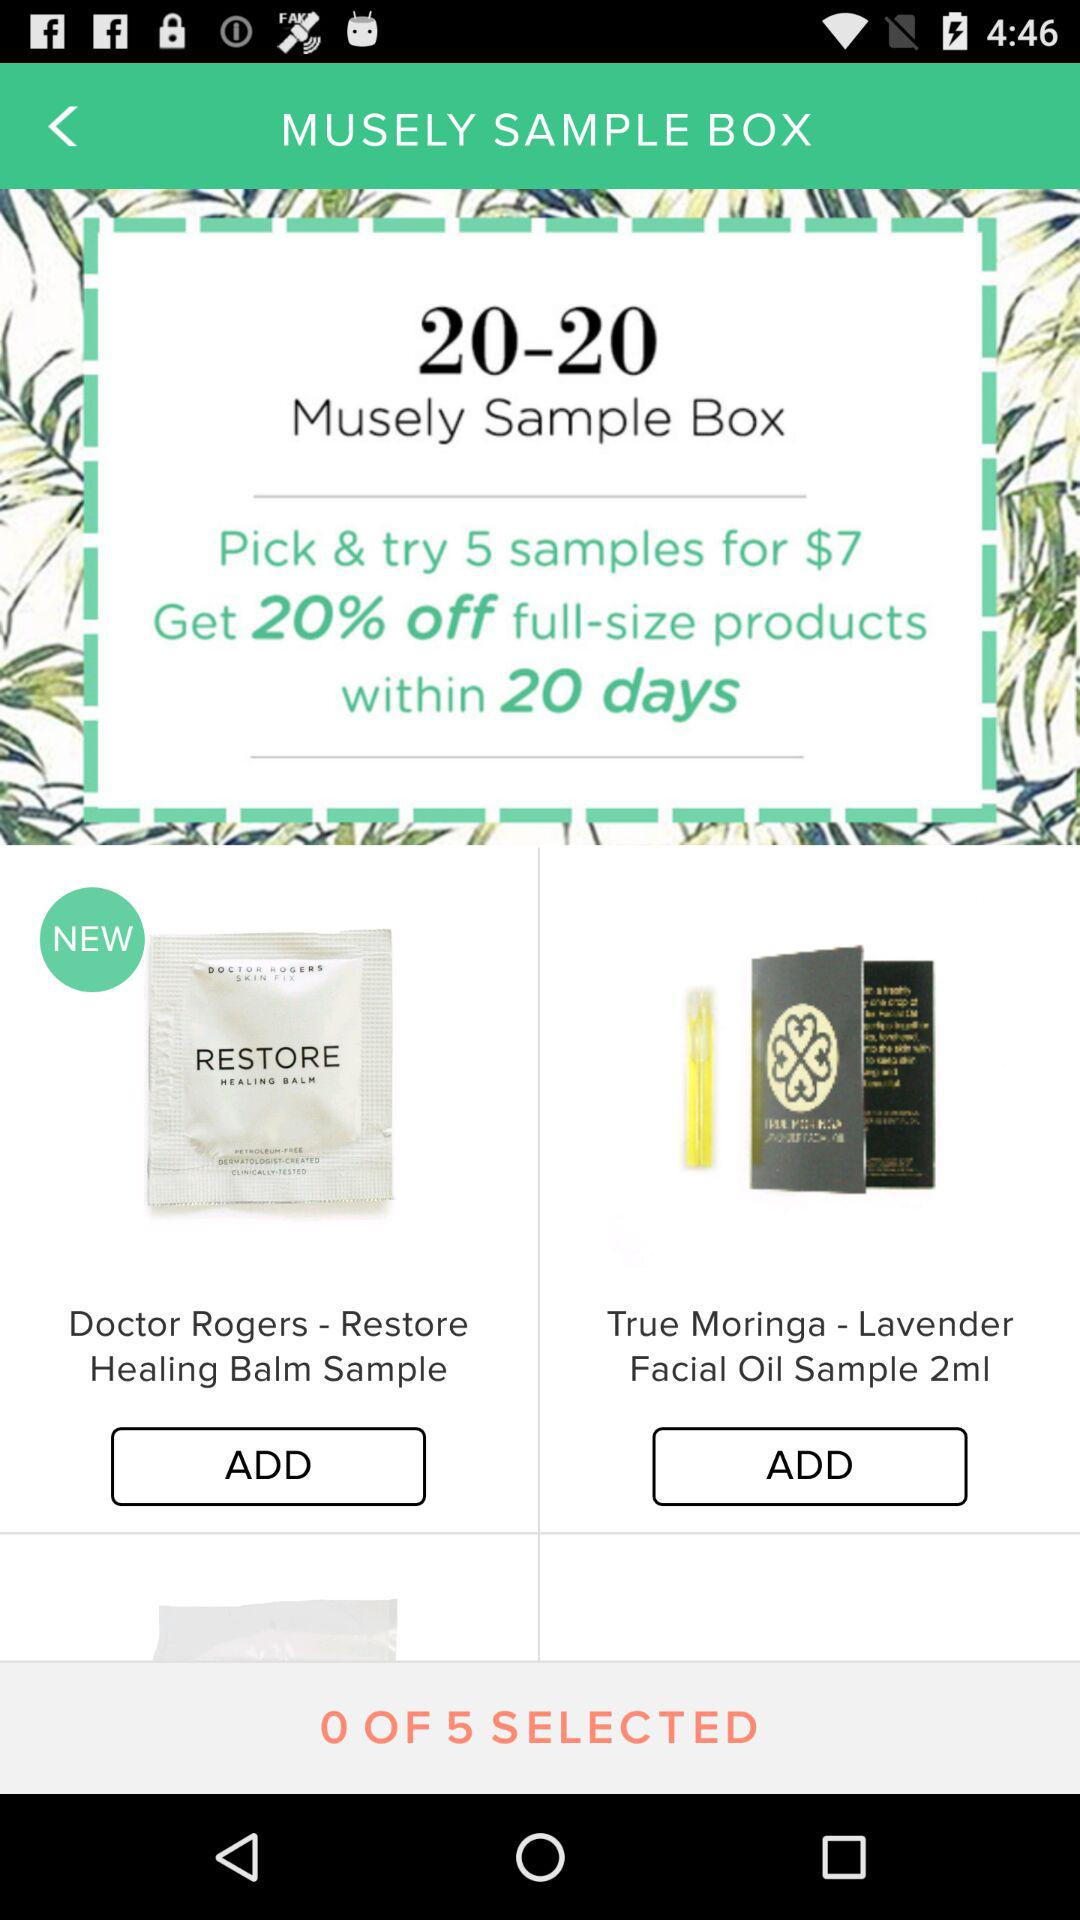How many samples are in the Musely Sample Box?
Answer the question using a single word or phrase. 5 